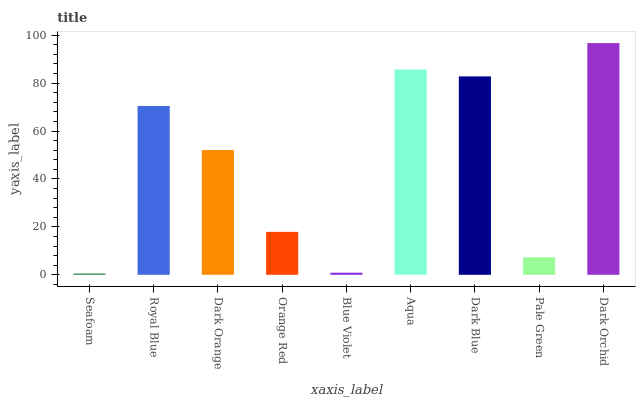Is Seafoam the minimum?
Answer yes or no. Yes. Is Dark Orchid the maximum?
Answer yes or no. Yes. Is Royal Blue the minimum?
Answer yes or no. No. Is Royal Blue the maximum?
Answer yes or no. No. Is Royal Blue greater than Seafoam?
Answer yes or no. Yes. Is Seafoam less than Royal Blue?
Answer yes or no. Yes. Is Seafoam greater than Royal Blue?
Answer yes or no. No. Is Royal Blue less than Seafoam?
Answer yes or no. No. Is Dark Orange the high median?
Answer yes or no. Yes. Is Dark Orange the low median?
Answer yes or no. Yes. Is Dark Orchid the high median?
Answer yes or no. No. Is Seafoam the low median?
Answer yes or no. No. 